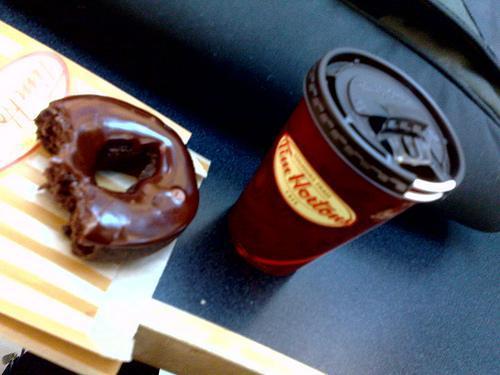How many donuts are pictured?
Give a very brief answer. 1. 